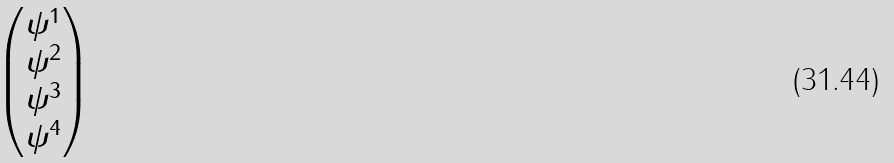<formula> <loc_0><loc_0><loc_500><loc_500>\begin{pmatrix} \psi ^ { 1 } \\ \psi ^ { 2 } \\ \psi ^ { 3 } \\ \psi ^ { 4 } \end{pmatrix}</formula> 